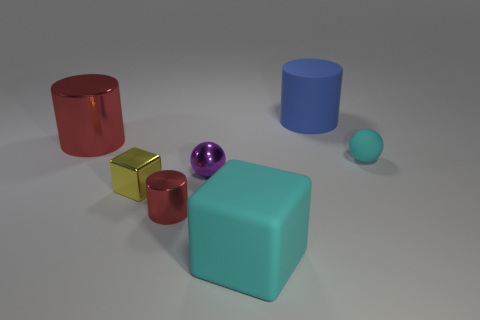Is there a big cyan object made of the same material as the tiny cylinder?
Offer a very short reply. No. What color is the other small thing that is the same shape as the purple metallic thing?
Your answer should be very brief. Cyan. Are there fewer blue matte things that are behind the small purple metal ball than rubber things on the left side of the cyan sphere?
Provide a succinct answer. Yes. What number of other objects are there of the same shape as the large red metal object?
Give a very brief answer. 2. Is the number of large metal cylinders that are behind the blue matte cylinder less than the number of big red objects?
Provide a succinct answer. Yes. What material is the big cyan thing in front of the large matte cylinder?
Give a very brief answer. Rubber. How many other things are there of the same size as the purple metallic object?
Keep it short and to the point. 3. Is the number of small cyan spheres less than the number of gray cubes?
Your answer should be very brief. No. What shape is the large cyan matte thing?
Offer a very short reply. Cube. There is a big matte object to the left of the big blue cylinder; is its color the same as the small matte sphere?
Make the answer very short. Yes. 